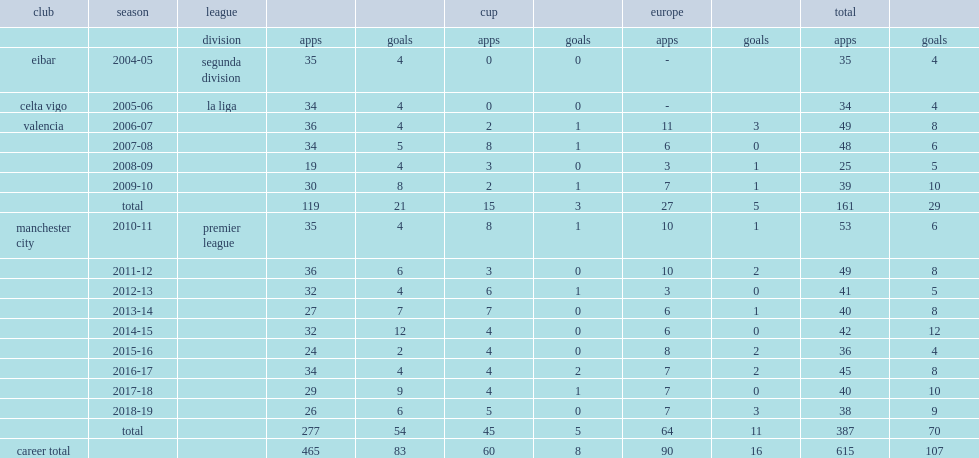Which club did david silva play for in 2013-14? Manchester city. 